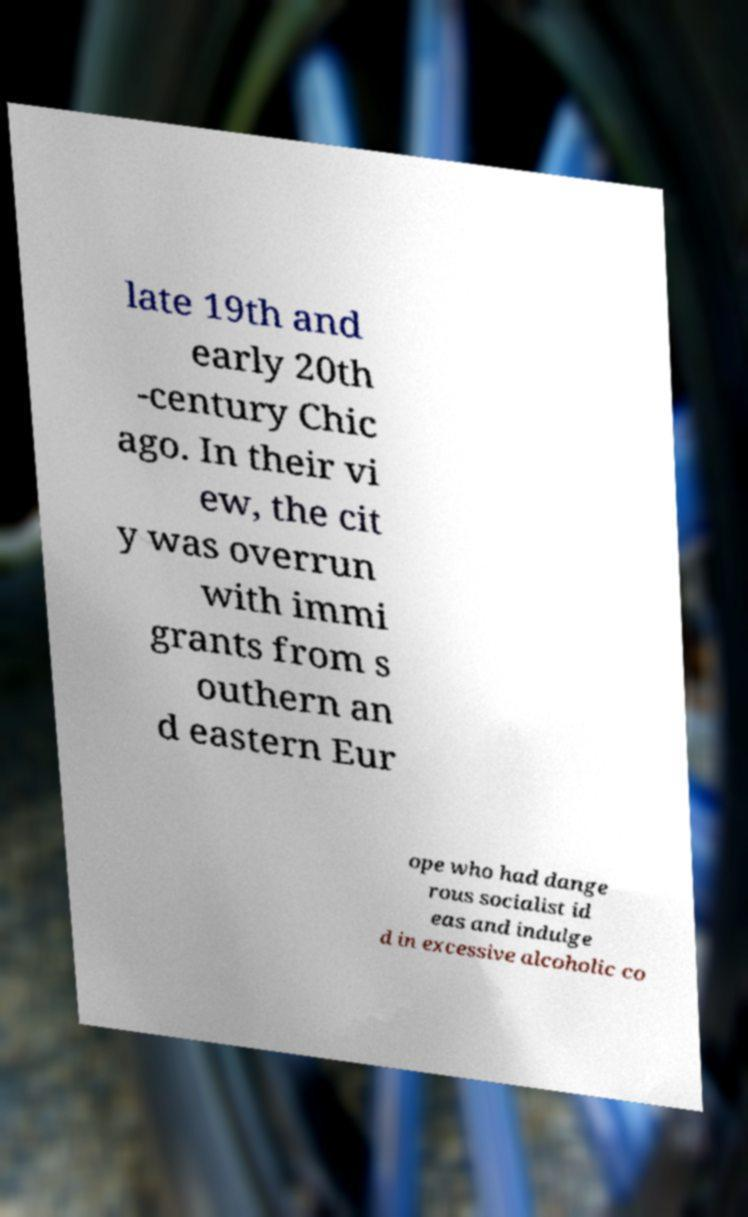Please read and relay the text visible in this image. What does it say? late 19th and early 20th -century Chic ago. In their vi ew, the cit y was overrun with immi grants from s outhern an d eastern Eur ope who had dange rous socialist id eas and indulge d in excessive alcoholic co 